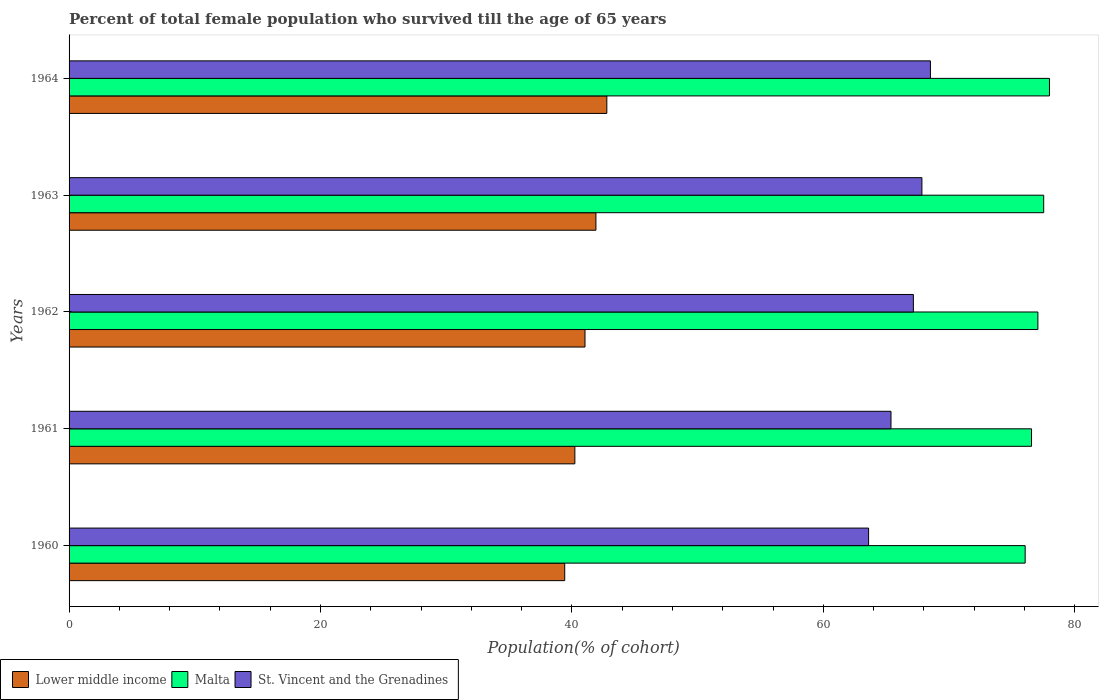How many different coloured bars are there?
Keep it short and to the point. 3. How many groups of bars are there?
Provide a succinct answer. 5. Are the number of bars per tick equal to the number of legend labels?
Keep it short and to the point. Yes. How many bars are there on the 3rd tick from the top?
Ensure brevity in your answer.  3. How many bars are there on the 2nd tick from the bottom?
Your answer should be very brief. 3. What is the label of the 1st group of bars from the top?
Keep it short and to the point. 1964. What is the percentage of total female population who survived till the age of 65 years in Malta in 1962?
Your response must be concise. 77.07. Across all years, what is the maximum percentage of total female population who survived till the age of 65 years in Lower middle income?
Make the answer very short. 42.78. Across all years, what is the minimum percentage of total female population who survived till the age of 65 years in Lower middle income?
Provide a short and direct response. 39.43. In which year was the percentage of total female population who survived till the age of 65 years in Malta maximum?
Offer a very short reply. 1964. In which year was the percentage of total female population who survived till the age of 65 years in Malta minimum?
Provide a succinct answer. 1960. What is the total percentage of total female population who survived till the age of 65 years in St. Vincent and the Grenadines in the graph?
Provide a short and direct response. 332.53. What is the difference between the percentage of total female population who survived till the age of 65 years in Lower middle income in 1962 and that in 1963?
Ensure brevity in your answer.  -0.87. What is the difference between the percentage of total female population who survived till the age of 65 years in Malta in 1964 and the percentage of total female population who survived till the age of 65 years in St. Vincent and the Grenadines in 1963?
Provide a short and direct response. 10.15. What is the average percentage of total female population who survived till the age of 65 years in Malta per year?
Make the answer very short. 77.05. In the year 1963, what is the difference between the percentage of total female population who survived till the age of 65 years in St. Vincent and the Grenadines and percentage of total female population who survived till the age of 65 years in Malta?
Your response must be concise. -9.69. What is the ratio of the percentage of total female population who survived till the age of 65 years in Malta in 1962 to that in 1964?
Ensure brevity in your answer.  0.99. Is the percentage of total female population who survived till the age of 65 years in Malta in 1962 less than that in 1963?
Provide a short and direct response. Yes. What is the difference between the highest and the second highest percentage of total female population who survived till the age of 65 years in St. Vincent and the Grenadines?
Make the answer very short. 0.68. What is the difference between the highest and the lowest percentage of total female population who survived till the age of 65 years in Malta?
Offer a terse response. 1.93. Is the sum of the percentage of total female population who survived till the age of 65 years in St. Vincent and the Grenadines in 1961 and 1962 greater than the maximum percentage of total female population who survived till the age of 65 years in Lower middle income across all years?
Your answer should be compact. Yes. What does the 2nd bar from the top in 1961 represents?
Your answer should be very brief. Malta. What does the 3rd bar from the bottom in 1964 represents?
Offer a very short reply. St. Vincent and the Grenadines. Is it the case that in every year, the sum of the percentage of total female population who survived till the age of 65 years in Lower middle income and percentage of total female population who survived till the age of 65 years in Malta is greater than the percentage of total female population who survived till the age of 65 years in St. Vincent and the Grenadines?
Offer a terse response. Yes. Are the values on the major ticks of X-axis written in scientific E-notation?
Provide a short and direct response. No. Where does the legend appear in the graph?
Provide a short and direct response. Bottom left. How many legend labels are there?
Your response must be concise. 3. How are the legend labels stacked?
Offer a terse response. Horizontal. What is the title of the graph?
Keep it short and to the point. Percent of total female population who survived till the age of 65 years. What is the label or title of the X-axis?
Your response must be concise. Population(% of cohort). What is the label or title of the Y-axis?
Ensure brevity in your answer.  Years. What is the Population(% of cohort) of Lower middle income in 1960?
Keep it short and to the point. 39.43. What is the Population(% of cohort) in Malta in 1960?
Provide a succinct answer. 76.06. What is the Population(% of cohort) of St. Vincent and the Grenadines in 1960?
Offer a terse response. 63.6. What is the Population(% of cohort) in Lower middle income in 1961?
Provide a short and direct response. 40.24. What is the Population(% of cohort) of Malta in 1961?
Your response must be concise. 76.57. What is the Population(% of cohort) in St. Vincent and the Grenadines in 1961?
Give a very brief answer. 65.39. What is the Population(% of cohort) in Lower middle income in 1962?
Give a very brief answer. 41.04. What is the Population(% of cohort) in Malta in 1962?
Your answer should be very brief. 77.07. What is the Population(% of cohort) in St. Vincent and the Grenadines in 1962?
Provide a succinct answer. 67.17. What is the Population(% of cohort) of Lower middle income in 1963?
Provide a succinct answer. 41.91. What is the Population(% of cohort) of Malta in 1963?
Make the answer very short. 77.53. What is the Population(% of cohort) of St. Vincent and the Grenadines in 1963?
Your answer should be compact. 67.85. What is the Population(% of cohort) in Lower middle income in 1964?
Ensure brevity in your answer.  42.78. What is the Population(% of cohort) of Malta in 1964?
Make the answer very short. 77.99. What is the Population(% of cohort) in St. Vincent and the Grenadines in 1964?
Your response must be concise. 68.52. Across all years, what is the maximum Population(% of cohort) of Lower middle income?
Keep it short and to the point. 42.78. Across all years, what is the maximum Population(% of cohort) of Malta?
Offer a very short reply. 77.99. Across all years, what is the maximum Population(% of cohort) in St. Vincent and the Grenadines?
Ensure brevity in your answer.  68.52. Across all years, what is the minimum Population(% of cohort) in Lower middle income?
Make the answer very short. 39.43. Across all years, what is the minimum Population(% of cohort) of Malta?
Offer a terse response. 76.06. Across all years, what is the minimum Population(% of cohort) of St. Vincent and the Grenadines?
Your response must be concise. 63.6. What is the total Population(% of cohort) in Lower middle income in the graph?
Provide a succinct answer. 205.4. What is the total Population(% of cohort) in Malta in the graph?
Your answer should be compact. 385.23. What is the total Population(% of cohort) of St. Vincent and the Grenadines in the graph?
Your response must be concise. 332.53. What is the difference between the Population(% of cohort) of Lower middle income in 1960 and that in 1961?
Offer a very short reply. -0.81. What is the difference between the Population(% of cohort) in Malta in 1960 and that in 1961?
Offer a very short reply. -0.51. What is the difference between the Population(% of cohort) in St. Vincent and the Grenadines in 1960 and that in 1961?
Ensure brevity in your answer.  -1.78. What is the difference between the Population(% of cohort) of Lower middle income in 1960 and that in 1962?
Provide a short and direct response. -1.61. What is the difference between the Population(% of cohort) in Malta in 1960 and that in 1962?
Offer a terse response. -1.01. What is the difference between the Population(% of cohort) in St. Vincent and the Grenadines in 1960 and that in 1962?
Ensure brevity in your answer.  -3.56. What is the difference between the Population(% of cohort) in Lower middle income in 1960 and that in 1963?
Provide a succinct answer. -2.48. What is the difference between the Population(% of cohort) of Malta in 1960 and that in 1963?
Ensure brevity in your answer.  -1.47. What is the difference between the Population(% of cohort) of St. Vincent and the Grenadines in 1960 and that in 1963?
Your answer should be compact. -4.24. What is the difference between the Population(% of cohort) of Lower middle income in 1960 and that in 1964?
Give a very brief answer. -3.35. What is the difference between the Population(% of cohort) in Malta in 1960 and that in 1964?
Ensure brevity in your answer.  -1.94. What is the difference between the Population(% of cohort) in St. Vincent and the Grenadines in 1960 and that in 1964?
Your answer should be very brief. -4.92. What is the difference between the Population(% of cohort) of Lower middle income in 1961 and that in 1962?
Keep it short and to the point. -0.81. What is the difference between the Population(% of cohort) in Malta in 1961 and that in 1962?
Offer a terse response. -0.51. What is the difference between the Population(% of cohort) of St. Vincent and the Grenadines in 1961 and that in 1962?
Provide a succinct answer. -1.78. What is the difference between the Population(% of cohort) in Lower middle income in 1961 and that in 1963?
Make the answer very short. -1.68. What is the difference between the Population(% of cohort) in Malta in 1961 and that in 1963?
Provide a succinct answer. -0.97. What is the difference between the Population(% of cohort) in St. Vincent and the Grenadines in 1961 and that in 1963?
Give a very brief answer. -2.46. What is the difference between the Population(% of cohort) in Lower middle income in 1961 and that in 1964?
Ensure brevity in your answer.  -2.54. What is the difference between the Population(% of cohort) of Malta in 1961 and that in 1964?
Give a very brief answer. -1.43. What is the difference between the Population(% of cohort) of St. Vincent and the Grenadines in 1961 and that in 1964?
Offer a terse response. -3.14. What is the difference between the Population(% of cohort) of Lower middle income in 1962 and that in 1963?
Give a very brief answer. -0.87. What is the difference between the Population(% of cohort) in Malta in 1962 and that in 1963?
Provide a short and direct response. -0.46. What is the difference between the Population(% of cohort) in St. Vincent and the Grenadines in 1962 and that in 1963?
Your response must be concise. -0.68. What is the difference between the Population(% of cohort) in Lower middle income in 1962 and that in 1964?
Keep it short and to the point. -1.74. What is the difference between the Population(% of cohort) in Malta in 1962 and that in 1964?
Offer a very short reply. -0.92. What is the difference between the Population(% of cohort) of St. Vincent and the Grenadines in 1962 and that in 1964?
Keep it short and to the point. -1.36. What is the difference between the Population(% of cohort) in Lower middle income in 1963 and that in 1964?
Keep it short and to the point. -0.87. What is the difference between the Population(% of cohort) in Malta in 1963 and that in 1964?
Provide a succinct answer. -0.46. What is the difference between the Population(% of cohort) in St. Vincent and the Grenadines in 1963 and that in 1964?
Your response must be concise. -0.68. What is the difference between the Population(% of cohort) in Lower middle income in 1960 and the Population(% of cohort) in Malta in 1961?
Ensure brevity in your answer.  -37.14. What is the difference between the Population(% of cohort) in Lower middle income in 1960 and the Population(% of cohort) in St. Vincent and the Grenadines in 1961?
Make the answer very short. -25.95. What is the difference between the Population(% of cohort) in Malta in 1960 and the Population(% of cohort) in St. Vincent and the Grenadines in 1961?
Provide a succinct answer. 10.67. What is the difference between the Population(% of cohort) of Lower middle income in 1960 and the Population(% of cohort) of Malta in 1962?
Make the answer very short. -37.64. What is the difference between the Population(% of cohort) in Lower middle income in 1960 and the Population(% of cohort) in St. Vincent and the Grenadines in 1962?
Your response must be concise. -27.74. What is the difference between the Population(% of cohort) in Malta in 1960 and the Population(% of cohort) in St. Vincent and the Grenadines in 1962?
Provide a short and direct response. 8.89. What is the difference between the Population(% of cohort) in Lower middle income in 1960 and the Population(% of cohort) in Malta in 1963?
Offer a terse response. -38.1. What is the difference between the Population(% of cohort) in Lower middle income in 1960 and the Population(% of cohort) in St. Vincent and the Grenadines in 1963?
Provide a short and direct response. -28.42. What is the difference between the Population(% of cohort) of Malta in 1960 and the Population(% of cohort) of St. Vincent and the Grenadines in 1963?
Make the answer very short. 8.21. What is the difference between the Population(% of cohort) of Lower middle income in 1960 and the Population(% of cohort) of Malta in 1964?
Your answer should be very brief. -38.56. What is the difference between the Population(% of cohort) in Lower middle income in 1960 and the Population(% of cohort) in St. Vincent and the Grenadines in 1964?
Your response must be concise. -29.09. What is the difference between the Population(% of cohort) of Malta in 1960 and the Population(% of cohort) of St. Vincent and the Grenadines in 1964?
Give a very brief answer. 7.53. What is the difference between the Population(% of cohort) in Lower middle income in 1961 and the Population(% of cohort) in Malta in 1962?
Your answer should be compact. -36.84. What is the difference between the Population(% of cohort) in Lower middle income in 1961 and the Population(% of cohort) in St. Vincent and the Grenadines in 1962?
Ensure brevity in your answer.  -26.93. What is the difference between the Population(% of cohort) in Malta in 1961 and the Population(% of cohort) in St. Vincent and the Grenadines in 1962?
Your answer should be compact. 9.4. What is the difference between the Population(% of cohort) of Lower middle income in 1961 and the Population(% of cohort) of Malta in 1963?
Your response must be concise. -37.3. What is the difference between the Population(% of cohort) in Lower middle income in 1961 and the Population(% of cohort) in St. Vincent and the Grenadines in 1963?
Provide a short and direct response. -27.61. What is the difference between the Population(% of cohort) of Malta in 1961 and the Population(% of cohort) of St. Vincent and the Grenadines in 1963?
Give a very brief answer. 8.72. What is the difference between the Population(% of cohort) of Lower middle income in 1961 and the Population(% of cohort) of Malta in 1964?
Your answer should be very brief. -37.76. What is the difference between the Population(% of cohort) in Lower middle income in 1961 and the Population(% of cohort) in St. Vincent and the Grenadines in 1964?
Keep it short and to the point. -28.29. What is the difference between the Population(% of cohort) in Malta in 1961 and the Population(% of cohort) in St. Vincent and the Grenadines in 1964?
Offer a very short reply. 8.04. What is the difference between the Population(% of cohort) in Lower middle income in 1962 and the Population(% of cohort) in Malta in 1963?
Give a very brief answer. -36.49. What is the difference between the Population(% of cohort) in Lower middle income in 1962 and the Population(% of cohort) in St. Vincent and the Grenadines in 1963?
Give a very brief answer. -26.8. What is the difference between the Population(% of cohort) in Malta in 1962 and the Population(% of cohort) in St. Vincent and the Grenadines in 1963?
Your answer should be very brief. 9.23. What is the difference between the Population(% of cohort) in Lower middle income in 1962 and the Population(% of cohort) in Malta in 1964?
Offer a very short reply. -36.95. What is the difference between the Population(% of cohort) in Lower middle income in 1962 and the Population(% of cohort) in St. Vincent and the Grenadines in 1964?
Give a very brief answer. -27.48. What is the difference between the Population(% of cohort) of Malta in 1962 and the Population(% of cohort) of St. Vincent and the Grenadines in 1964?
Your answer should be very brief. 8.55. What is the difference between the Population(% of cohort) in Lower middle income in 1963 and the Population(% of cohort) in Malta in 1964?
Your response must be concise. -36.08. What is the difference between the Population(% of cohort) in Lower middle income in 1963 and the Population(% of cohort) in St. Vincent and the Grenadines in 1964?
Offer a terse response. -26.61. What is the difference between the Population(% of cohort) of Malta in 1963 and the Population(% of cohort) of St. Vincent and the Grenadines in 1964?
Provide a succinct answer. 9.01. What is the average Population(% of cohort) of Lower middle income per year?
Keep it short and to the point. 41.08. What is the average Population(% of cohort) of Malta per year?
Provide a short and direct response. 77.05. What is the average Population(% of cohort) of St. Vincent and the Grenadines per year?
Offer a very short reply. 66.51. In the year 1960, what is the difference between the Population(% of cohort) of Lower middle income and Population(% of cohort) of Malta?
Your response must be concise. -36.63. In the year 1960, what is the difference between the Population(% of cohort) of Lower middle income and Population(% of cohort) of St. Vincent and the Grenadines?
Your answer should be very brief. -24.17. In the year 1960, what is the difference between the Population(% of cohort) of Malta and Population(% of cohort) of St. Vincent and the Grenadines?
Offer a terse response. 12.45. In the year 1961, what is the difference between the Population(% of cohort) in Lower middle income and Population(% of cohort) in Malta?
Keep it short and to the point. -36.33. In the year 1961, what is the difference between the Population(% of cohort) in Lower middle income and Population(% of cohort) in St. Vincent and the Grenadines?
Provide a succinct answer. -25.15. In the year 1961, what is the difference between the Population(% of cohort) of Malta and Population(% of cohort) of St. Vincent and the Grenadines?
Give a very brief answer. 11.18. In the year 1962, what is the difference between the Population(% of cohort) in Lower middle income and Population(% of cohort) in Malta?
Make the answer very short. -36.03. In the year 1962, what is the difference between the Population(% of cohort) in Lower middle income and Population(% of cohort) in St. Vincent and the Grenadines?
Offer a very short reply. -26.12. In the year 1962, what is the difference between the Population(% of cohort) in Malta and Population(% of cohort) in St. Vincent and the Grenadines?
Offer a very short reply. 9.91. In the year 1963, what is the difference between the Population(% of cohort) of Lower middle income and Population(% of cohort) of Malta?
Your answer should be very brief. -35.62. In the year 1963, what is the difference between the Population(% of cohort) in Lower middle income and Population(% of cohort) in St. Vincent and the Grenadines?
Offer a terse response. -25.93. In the year 1963, what is the difference between the Population(% of cohort) in Malta and Population(% of cohort) in St. Vincent and the Grenadines?
Offer a very short reply. 9.69. In the year 1964, what is the difference between the Population(% of cohort) of Lower middle income and Population(% of cohort) of Malta?
Provide a succinct answer. -35.21. In the year 1964, what is the difference between the Population(% of cohort) of Lower middle income and Population(% of cohort) of St. Vincent and the Grenadines?
Ensure brevity in your answer.  -25.74. In the year 1964, what is the difference between the Population(% of cohort) in Malta and Population(% of cohort) in St. Vincent and the Grenadines?
Keep it short and to the point. 9.47. What is the ratio of the Population(% of cohort) in St. Vincent and the Grenadines in 1960 to that in 1961?
Provide a succinct answer. 0.97. What is the ratio of the Population(% of cohort) in Lower middle income in 1960 to that in 1962?
Your response must be concise. 0.96. What is the ratio of the Population(% of cohort) in Malta in 1960 to that in 1962?
Your response must be concise. 0.99. What is the ratio of the Population(% of cohort) of St. Vincent and the Grenadines in 1960 to that in 1962?
Provide a succinct answer. 0.95. What is the ratio of the Population(% of cohort) of Lower middle income in 1960 to that in 1963?
Your response must be concise. 0.94. What is the ratio of the Population(% of cohort) of Malta in 1960 to that in 1963?
Make the answer very short. 0.98. What is the ratio of the Population(% of cohort) of St. Vincent and the Grenadines in 1960 to that in 1963?
Ensure brevity in your answer.  0.94. What is the ratio of the Population(% of cohort) in Lower middle income in 1960 to that in 1964?
Offer a terse response. 0.92. What is the ratio of the Population(% of cohort) in Malta in 1960 to that in 1964?
Make the answer very short. 0.98. What is the ratio of the Population(% of cohort) in St. Vincent and the Grenadines in 1960 to that in 1964?
Offer a terse response. 0.93. What is the ratio of the Population(% of cohort) of Lower middle income in 1961 to that in 1962?
Offer a terse response. 0.98. What is the ratio of the Population(% of cohort) of Malta in 1961 to that in 1962?
Provide a succinct answer. 0.99. What is the ratio of the Population(% of cohort) of St. Vincent and the Grenadines in 1961 to that in 1962?
Give a very brief answer. 0.97. What is the ratio of the Population(% of cohort) in Lower middle income in 1961 to that in 1963?
Your answer should be compact. 0.96. What is the ratio of the Population(% of cohort) in Malta in 1961 to that in 1963?
Provide a succinct answer. 0.99. What is the ratio of the Population(% of cohort) in St. Vincent and the Grenadines in 1961 to that in 1963?
Ensure brevity in your answer.  0.96. What is the ratio of the Population(% of cohort) of Lower middle income in 1961 to that in 1964?
Your answer should be very brief. 0.94. What is the ratio of the Population(% of cohort) of Malta in 1961 to that in 1964?
Make the answer very short. 0.98. What is the ratio of the Population(% of cohort) in St. Vincent and the Grenadines in 1961 to that in 1964?
Your answer should be compact. 0.95. What is the ratio of the Population(% of cohort) of Lower middle income in 1962 to that in 1963?
Your answer should be very brief. 0.98. What is the ratio of the Population(% of cohort) of Lower middle income in 1962 to that in 1964?
Your answer should be very brief. 0.96. What is the ratio of the Population(% of cohort) of Malta in 1962 to that in 1964?
Your answer should be compact. 0.99. What is the ratio of the Population(% of cohort) in St. Vincent and the Grenadines in 1962 to that in 1964?
Your response must be concise. 0.98. What is the ratio of the Population(% of cohort) of Lower middle income in 1963 to that in 1964?
Make the answer very short. 0.98. What is the ratio of the Population(% of cohort) in Malta in 1963 to that in 1964?
Offer a terse response. 0.99. What is the ratio of the Population(% of cohort) of St. Vincent and the Grenadines in 1963 to that in 1964?
Make the answer very short. 0.99. What is the difference between the highest and the second highest Population(% of cohort) of Lower middle income?
Offer a very short reply. 0.87. What is the difference between the highest and the second highest Population(% of cohort) in Malta?
Keep it short and to the point. 0.46. What is the difference between the highest and the second highest Population(% of cohort) in St. Vincent and the Grenadines?
Your answer should be compact. 0.68. What is the difference between the highest and the lowest Population(% of cohort) of Lower middle income?
Offer a terse response. 3.35. What is the difference between the highest and the lowest Population(% of cohort) in Malta?
Your response must be concise. 1.94. What is the difference between the highest and the lowest Population(% of cohort) of St. Vincent and the Grenadines?
Provide a short and direct response. 4.92. 